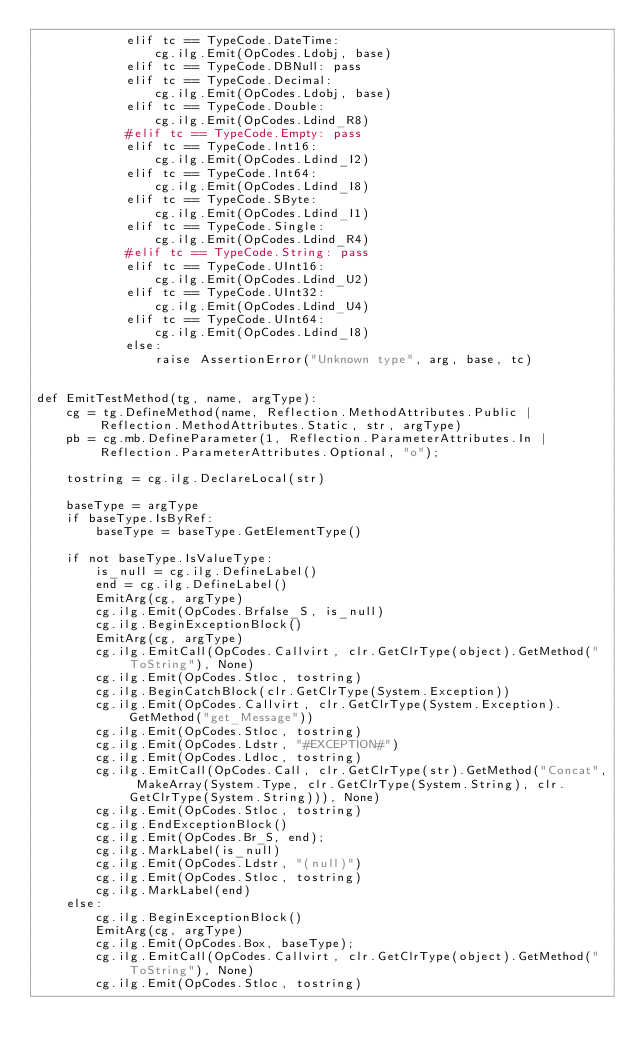Convert code to text. <code><loc_0><loc_0><loc_500><loc_500><_Python_>            elif tc == TypeCode.DateTime:
                cg.ilg.Emit(OpCodes.Ldobj, base)
            elif tc == TypeCode.DBNull: pass
            elif tc == TypeCode.Decimal:
                cg.ilg.Emit(OpCodes.Ldobj, base)
            elif tc == TypeCode.Double:
                cg.ilg.Emit(OpCodes.Ldind_R8)
            #elif tc == TypeCode.Empty: pass
            elif tc == TypeCode.Int16:
                cg.ilg.Emit(OpCodes.Ldind_I2)
            elif tc == TypeCode.Int64:
                cg.ilg.Emit(OpCodes.Ldind_I8)
            elif tc == TypeCode.SByte:
                cg.ilg.Emit(OpCodes.Ldind_I1)
            elif tc == TypeCode.Single:
                cg.ilg.Emit(OpCodes.Ldind_R4)
            #elif tc == TypeCode.String: pass
            elif tc == TypeCode.UInt16:
                cg.ilg.Emit(OpCodes.Ldind_U2)
            elif tc == TypeCode.UInt32:
                cg.ilg.Emit(OpCodes.Ldind_U4)
            elif tc == TypeCode.UInt64:
                cg.ilg.Emit(OpCodes.Ldind_I8)
            else:
                raise AssertionError("Unknown type", arg, base, tc)
            

def EmitTestMethod(tg, name, argType):
    cg = tg.DefineMethod(name, Reflection.MethodAttributes.Public | Reflection.MethodAttributes.Static, str, argType)
    pb = cg.mb.DefineParameter(1, Reflection.ParameterAttributes.In | Reflection.ParameterAttributes.Optional, "o");

    tostring = cg.ilg.DeclareLocal(str)

    baseType = argType
    if baseType.IsByRef:
        baseType = baseType.GetElementType()

    if not baseType.IsValueType:
        is_null = cg.ilg.DefineLabel()
        end = cg.ilg.DefineLabel()
        EmitArg(cg, argType)
        cg.ilg.Emit(OpCodes.Brfalse_S, is_null)
        cg.ilg.BeginExceptionBlock()
        EmitArg(cg, argType)
        cg.ilg.EmitCall(OpCodes.Callvirt, clr.GetClrType(object).GetMethod("ToString"), None)
        cg.ilg.Emit(OpCodes.Stloc, tostring)
        cg.ilg.BeginCatchBlock(clr.GetClrType(System.Exception))
        cg.ilg.Emit(OpCodes.Callvirt, clr.GetClrType(System.Exception).GetMethod("get_Message"))
        cg.ilg.Emit(OpCodes.Stloc, tostring)
        cg.ilg.Emit(OpCodes.Ldstr, "#EXCEPTION#")
        cg.ilg.Emit(OpCodes.Ldloc, tostring)
        cg.ilg.EmitCall(OpCodes.Call, clr.GetClrType(str).GetMethod("Concat", MakeArray(System.Type, clr.GetClrType(System.String), clr.GetClrType(System.String))), None)
        cg.ilg.Emit(OpCodes.Stloc, tostring)
        cg.ilg.EndExceptionBlock()
        cg.ilg.Emit(OpCodes.Br_S, end);
        cg.ilg.MarkLabel(is_null)
        cg.ilg.Emit(OpCodes.Ldstr, "(null)")
        cg.ilg.Emit(OpCodes.Stloc, tostring)
        cg.ilg.MarkLabel(end)
    else:
        cg.ilg.BeginExceptionBlock()
        EmitArg(cg, argType)
        cg.ilg.Emit(OpCodes.Box, baseType);
        cg.ilg.EmitCall(OpCodes.Callvirt, clr.GetClrType(object).GetMethod("ToString"), None)
        cg.ilg.Emit(OpCodes.Stloc, tostring)</code> 